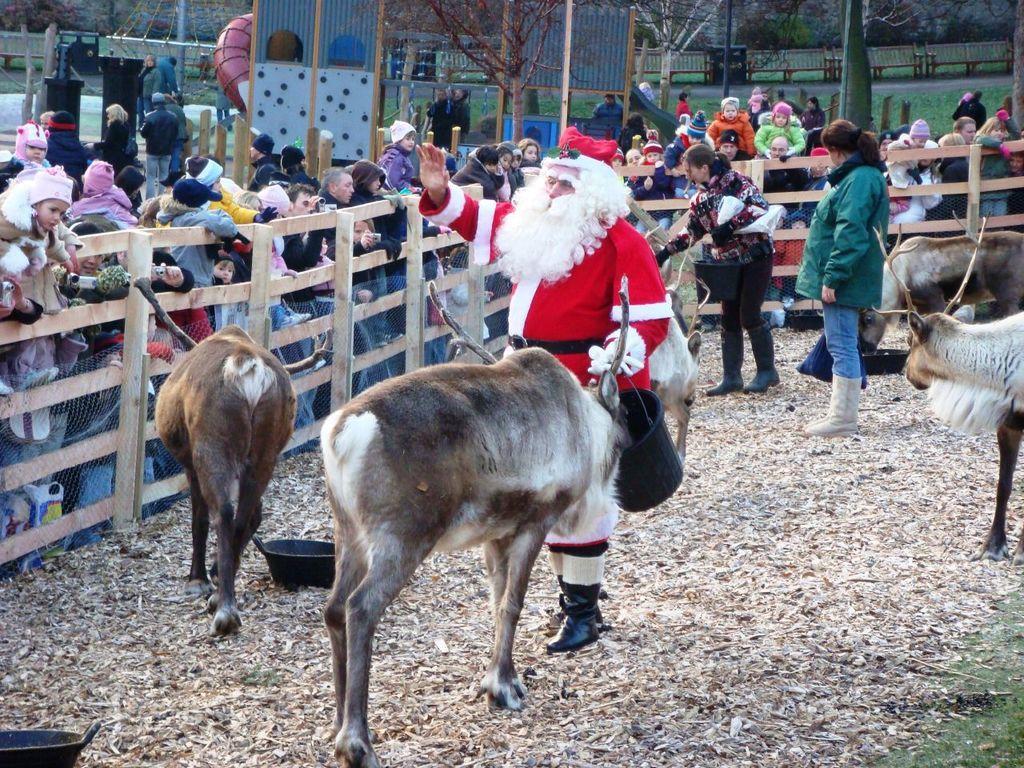Can you describe this image briefly? In this picture I can observe some animals. There are some people near the animals. I can observe a wooden railing. Behind the railing there are some people. I can observe men and women in this picture. In the background there are trees. 